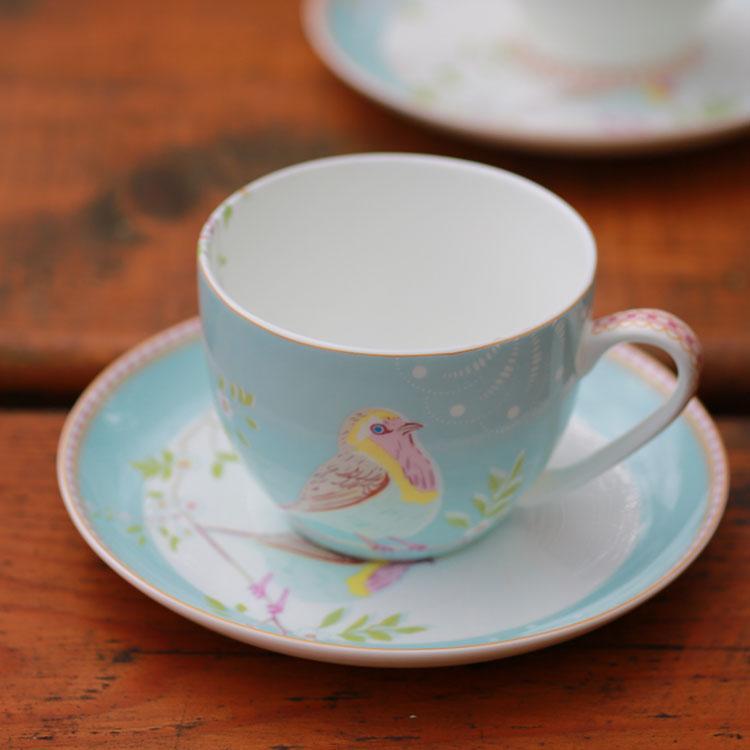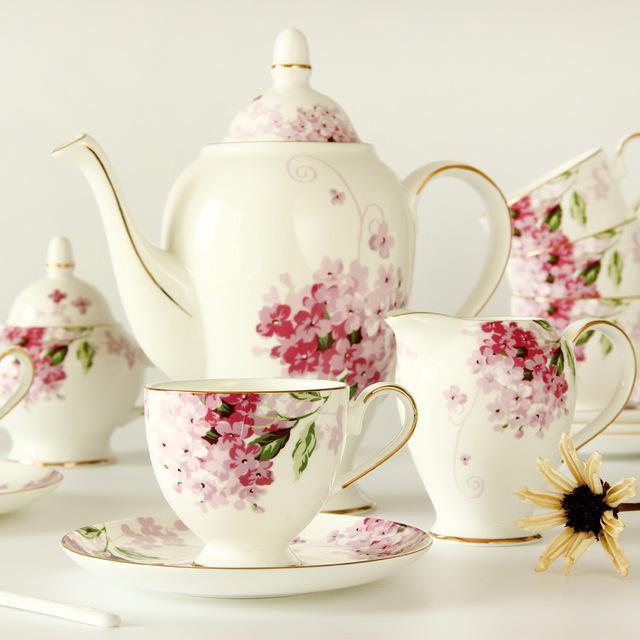The first image is the image on the left, the second image is the image on the right. For the images shown, is this caption "There is a teapot in one of the images." true? Answer yes or no. Yes. 